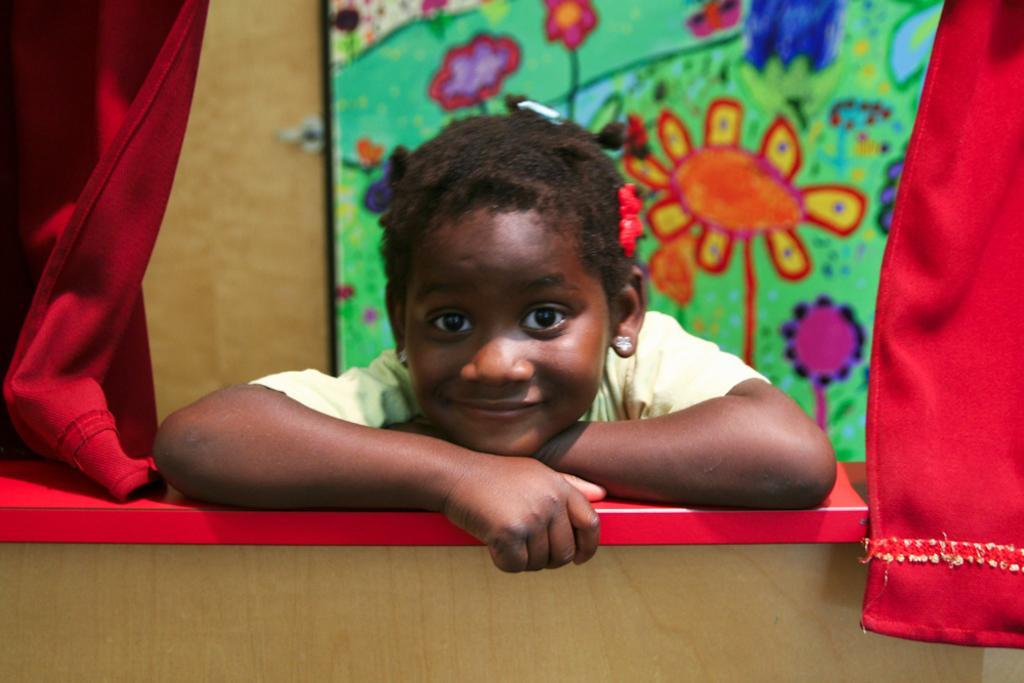Can you describe this image briefly? In this image I can see person. Back Side I can see colorful frame attached to the wall. Both-side I can see red color curtain. 